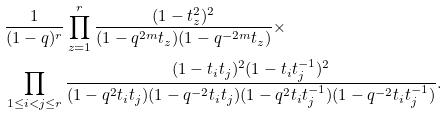<formula> <loc_0><loc_0><loc_500><loc_500>& \frac { 1 } { ( 1 - q ) ^ { r } } \prod _ { z = 1 } ^ { r } \frac { ( 1 - t _ { z } ^ { 2 } ) ^ { 2 } } { ( 1 - q ^ { 2 m } t _ { z } ) ( 1 - q ^ { - 2 m } t _ { z } ) } \times \\ & \prod _ { 1 \leq i < j \leq r } \frac { ( 1 - t _ { i } t _ { j } ) ^ { 2 } ( 1 - t _ { i } t _ { j } ^ { - 1 } ) ^ { 2 } } { ( 1 - q ^ { 2 } t _ { i } t _ { j } ) ( 1 - q ^ { - 2 } t _ { i } t _ { j } ) ( 1 - q ^ { 2 } t _ { i } t _ { j } ^ { - 1 } ) ( 1 - q ^ { - 2 } t _ { i } t _ { j } ^ { - 1 } ) } .</formula> 